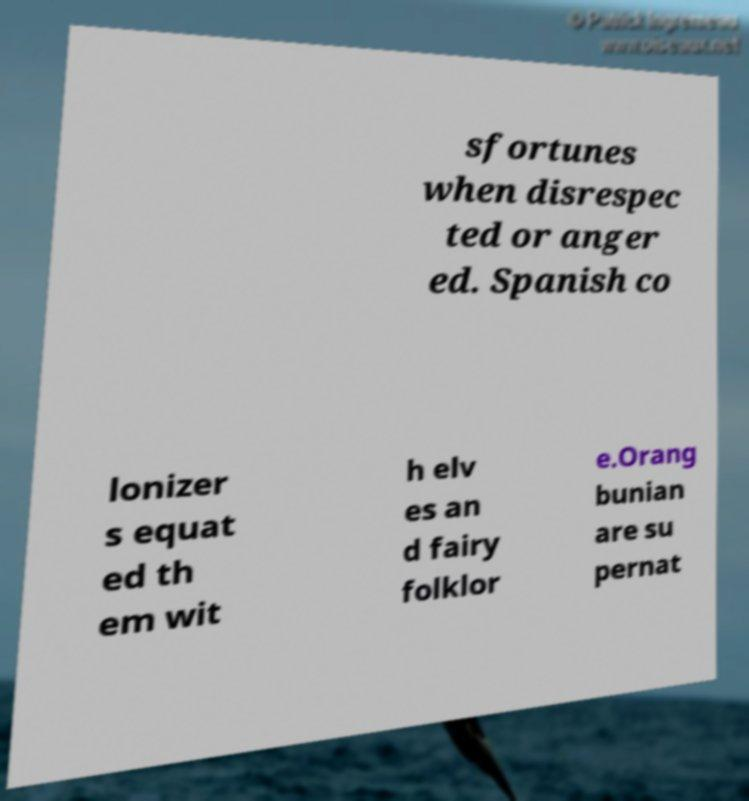For documentation purposes, I need the text within this image transcribed. Could you provide that? sfortunes when disrespec ted or anger ed. Spanish co lonizer s equat ed th em wit h elv es an d fairy folklor e.Orang bunian are su pernat 